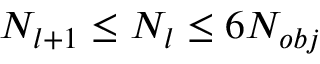Convert formula to latex. <formula><loc_0><loc_0><loc_500><loc_500>N _ { l + 1 } \leq N _ { l } \leq 6 N _ { o b j }</formula> 